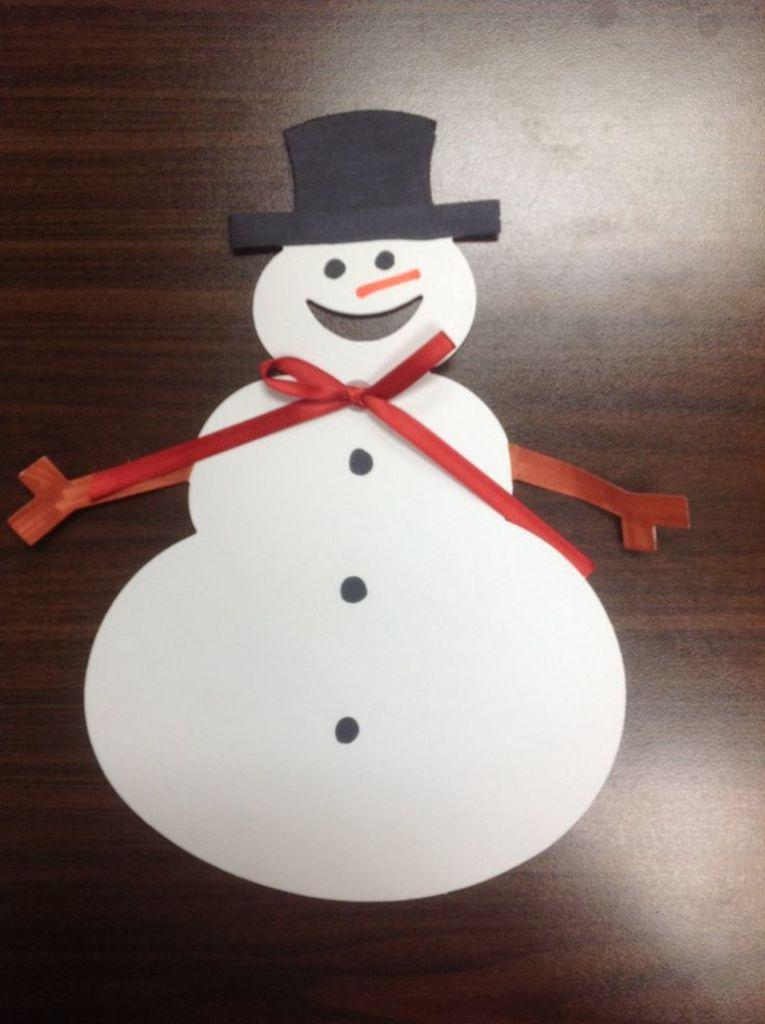What is the main subject of the image? The main subject of the image is a snowman craft. Where is the snowman craft located? The snowman craft is on a wooden object. What color is the ribbon in the image? The ribbon in the image is red. Is there a beggar asking for money near the snowman craft in the image? No, there is no beggar present in the image. Can you see the snowman craft giving a kiss to someone in the image? No, the snowman craft is an inanimate object and cannot give a kiss. 